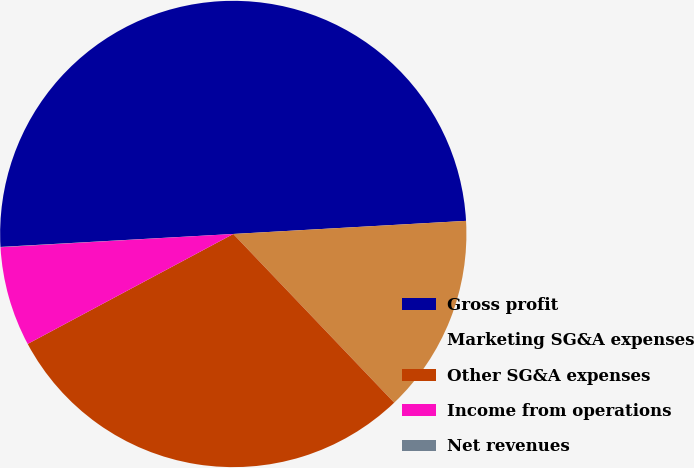Convert chart to OTSL. <chart><loc_0><loc_0><loc_500><loc_500><pie_chart><fcel>Gross profit<fcel>Marketing SG&A expenses<fcel>Other SG&A expenses<fcel>Income from operations<fcel>Net revenues<nl><fcel>49.99%<fcel>13.77%<fcel>29.31%<fcel>6.91%<fcel>0.02%<nl></chart> 